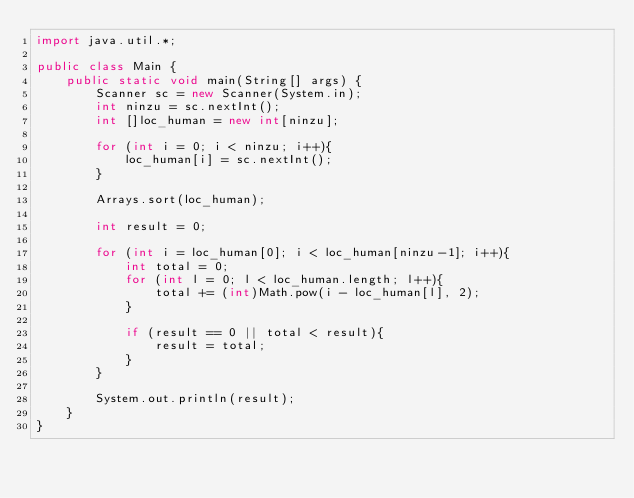<code> <loc_0><loc_0><loc_500><loc_500><_Java_>import java.util.*;

public class Main {
    public static void main(String[] args) {
        Scanner sc = new Scanner(System.in);
        int ninzu = sc.nextInt();
        int []loc_human = new int[ninzu];
        
        for (int i = 0; i < ninzu; i++){
            loc_human[i] = sc.nextInt();
        }
        
        Arrays.sort(loc_human);
        
        int result = 0;
        
        for (int i = loc_human[0]; i < loc_human[ninzu-1]; i++){
            int total = 0;
            for (int l = 0; l < loc_human.length; l++){
                total += (int)Math.pow(i - loc_human[l], 2);
            }
            
            if (result == 0 || total < result){
                result = total;
            } 
        } 

        System.out.println(result);
    }
}
</code> 